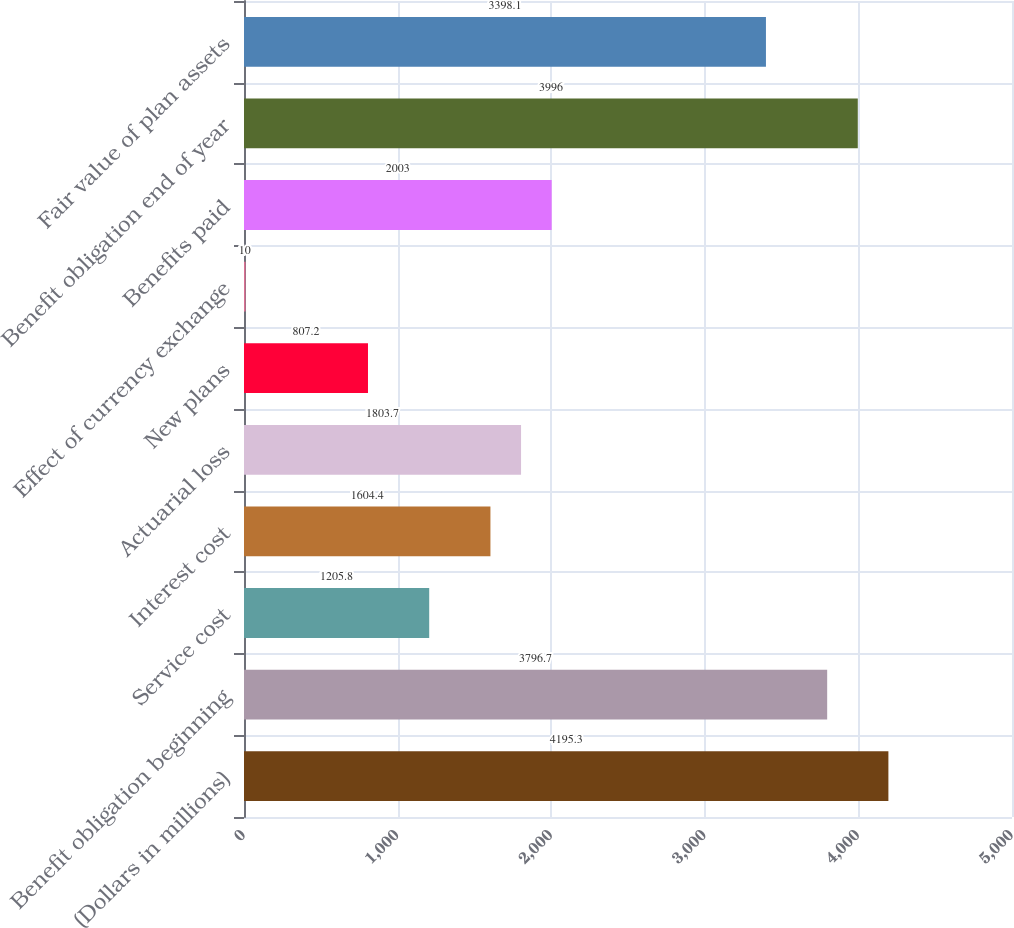Convert chart. <chart><loc_0><loc_0><loc_500><loc_500><bar_chart><fcel>(Dollars in millions)<fcel>Benefit obligation beginning<fcel>Service cost<fcel>Interest cost<fcel>Actuarial loss<fcel>New plans<fcel>Effect of currency exchange<fcel>Benefits paid<fcel>Benefit obligation end of year<fcel>Fair value of plan assets<nl><fcel>4195.3<fcel>3796.7<fcel>1205.8<fcel>1604.4<fcel>1803.7<fcel>807.2<fcel>10<fcel>2003<fcel>3996<fcel>3398.1<nl></chart> 